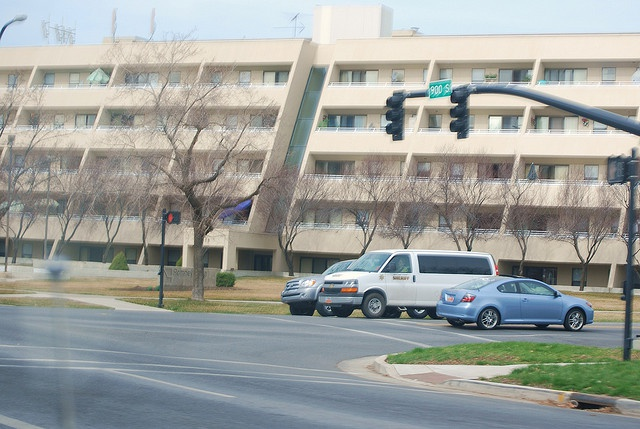Describe the objects in this image and their specific colors. I can see car in lightblue, lightgray, blue, and darkgray tones, truck in lightblue, lightgray, blue, and darkgray tones, car in lightblue, gray, and black tones, car in lightblue, black, darkgray, and lightgray tones, and traffic light in lightblue, blue, darkblue, gray, and black tones in this image. 